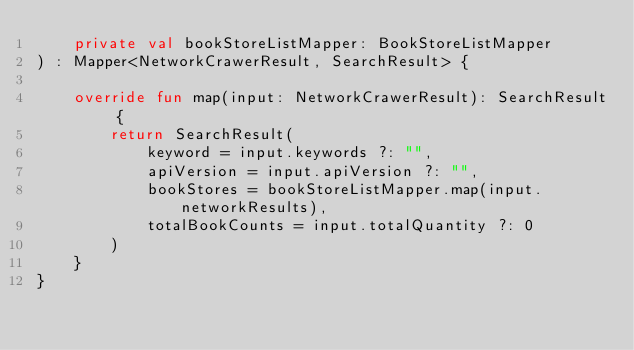<code> <loc_0><loc_0><loc_500><loc_500><_Kotlin_>    private val bookStoreListMapper: BookStoreListMapper
) : Mapper<NetworkCrawerResult, SearchResult> {

    override fun map(input: NetworkCrawerResult): SearchResult {
        return SearchResult(
            keyword = input.keywords ?: "",
            apiVersion = input.apiVersion ?: "",
            bookStores = bookStoreListMapper.map(input.networkResults),
            totalBookCounts = input.totalQuantity ?: 0
        )
    }
}</code> 